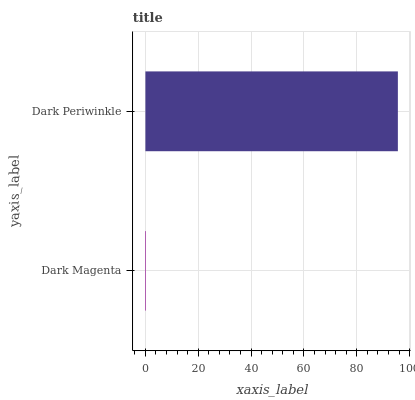Is Dark Magenta the minimum?
Answer yes or no. Yes. Is Dark Periwinkle the maximum?
Answer yes or no. Yes. Is Dark Periwinkle the minimum?
Answer yes or no. No. Is Dark Periwinkle greater than Dark Magenta?
Answer yes or no. Yes. Is Dark Magenta less than Dark Periwinkle?
Answer yes or no. Yes. Is Dark Magenta greater than Dark Periwinkle?
Answer yes or no. No. Is Dark Periwinkle less than Dark Magenta?
Answer yes or no. No. Is Dark Periwinkle the high median?
Answer yes or no. Yes. Is Dark Magenta the low median?
Answer yes or no. Yes. Is Dark Magenta the high median?
Answer yes or no. No. Is Dark Periwinkle the low median?
Answer yes or no. No. 